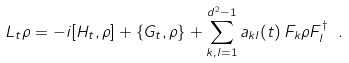<formula> <loc_0><loc_0><loc_500><loc_500>L _ { t } \rho = - i [ H _ { t } , \rho ] + \{ G _ { t } , \rho \} + \sum _ { k , l = 1 } ^ { d ^ { 2 } - 1 } a _ { k l } ( t ) \, F _ { k } \rho F _ { l } ^ { \dagger } \ .</formula> 